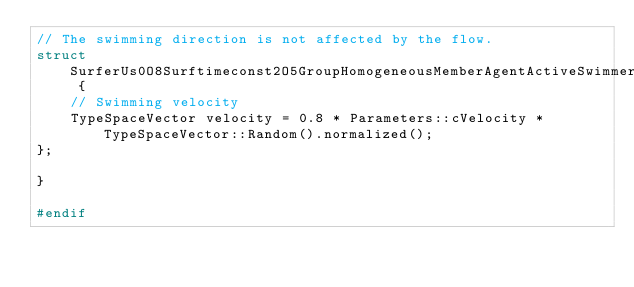Convert code to text. <code><loc_0><loc_0><loc_500><loc_500><_C_>// The swimming direction is not affected by the flow.
struct SurferUs0O8Surftimeconst2O5GroupHomogeneousMemberAgentActiveSwimmerStepParameters {
    // Swimming velocity
    TypeSpaceVector velocity = 0.8 * Parameters::cVelocity * TypeSpaceVector::Random().normalized();
};

}

#endif
</code> 